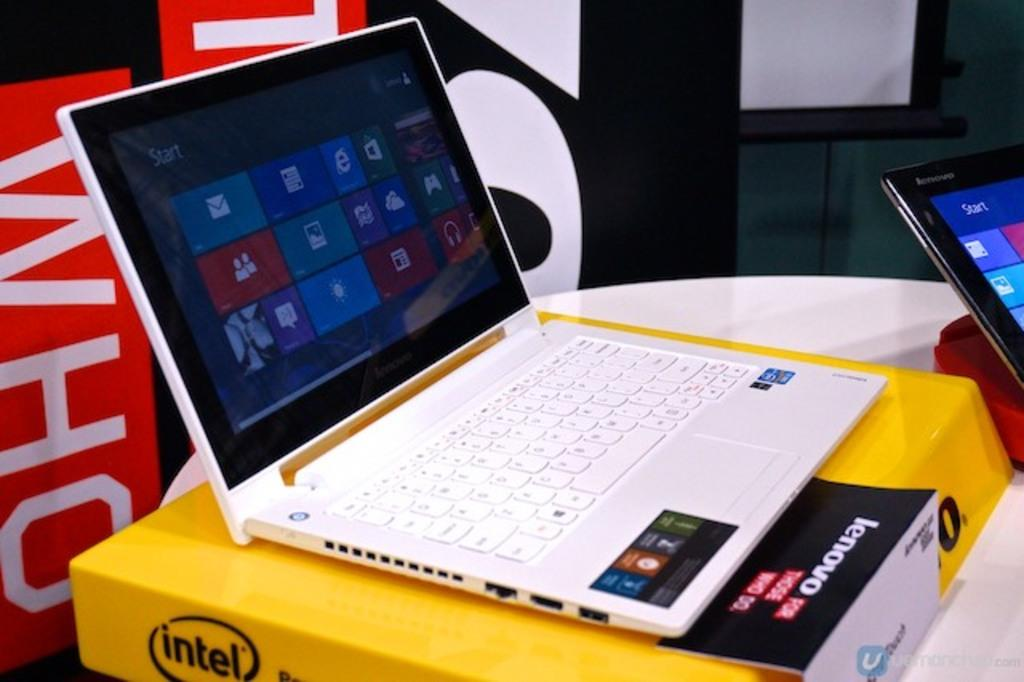What is placed on top of the laptop box in the image? There is a laptop on a laptop box in the image. Where is the laptop box located? The laptop box is on a table. Are there any other laptops visible in the image? Yes, there is another laptop on the right side of the image. What can be seen in the background of the image? There is a banner and a screen in the background of the image. What type of volleyball is being played on the laptop screen in the image? There is no volleyball being played on the laptop screen in the image; it is a laptop on a laptop box. Can you tell me the name of the mother of the person using the laptop in the image? There is no information about the person using the laptop or their mother in the image. 